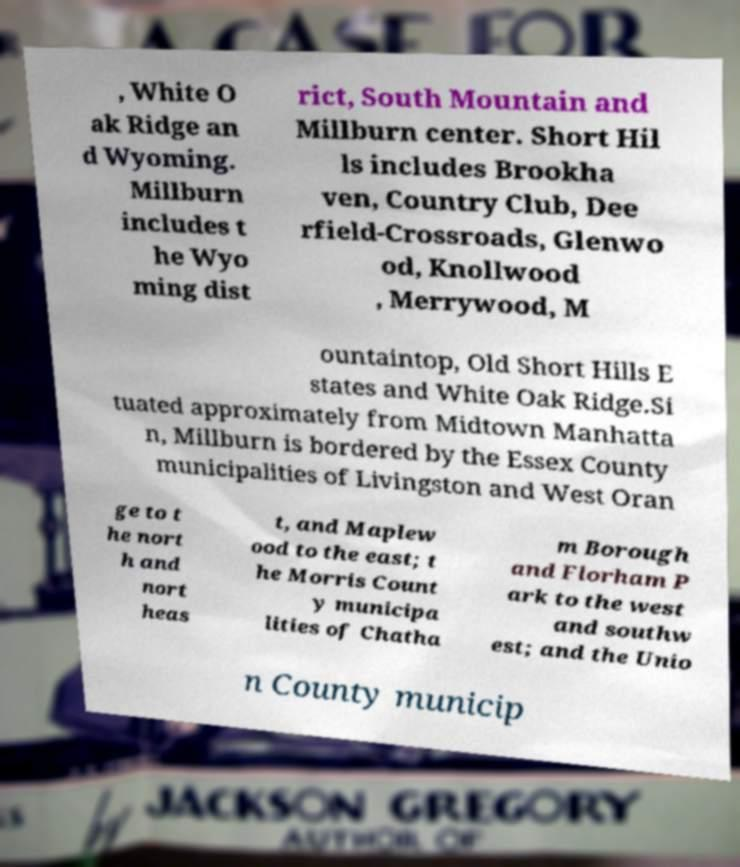There's text embedded in this image that I need extracted. Can you transcribe it verbatim? , White O ak Ridge an d Wyoming. Millburn includes t he Wyo ming dist rict, South Mountain and Millburn center. Short Hil ls includes Brookha ven, Country Club, Dee rfield-Crossroads, Glenwo od, Knollwood , Merrywood, M ountaintop, Old Short Hills E states and White Oak Ridge.Si tuated approximately from Midtown Manhatta n, Millburn is bordered by the Essex County municipalities of Livingston and West Oran ge to t he nort h and nort heas t, and Maplew ood to the east; t he Morris Count y municipa lities of Chatha m Borough and Florham P ark to the west and southw est; and the Unio n County municip 